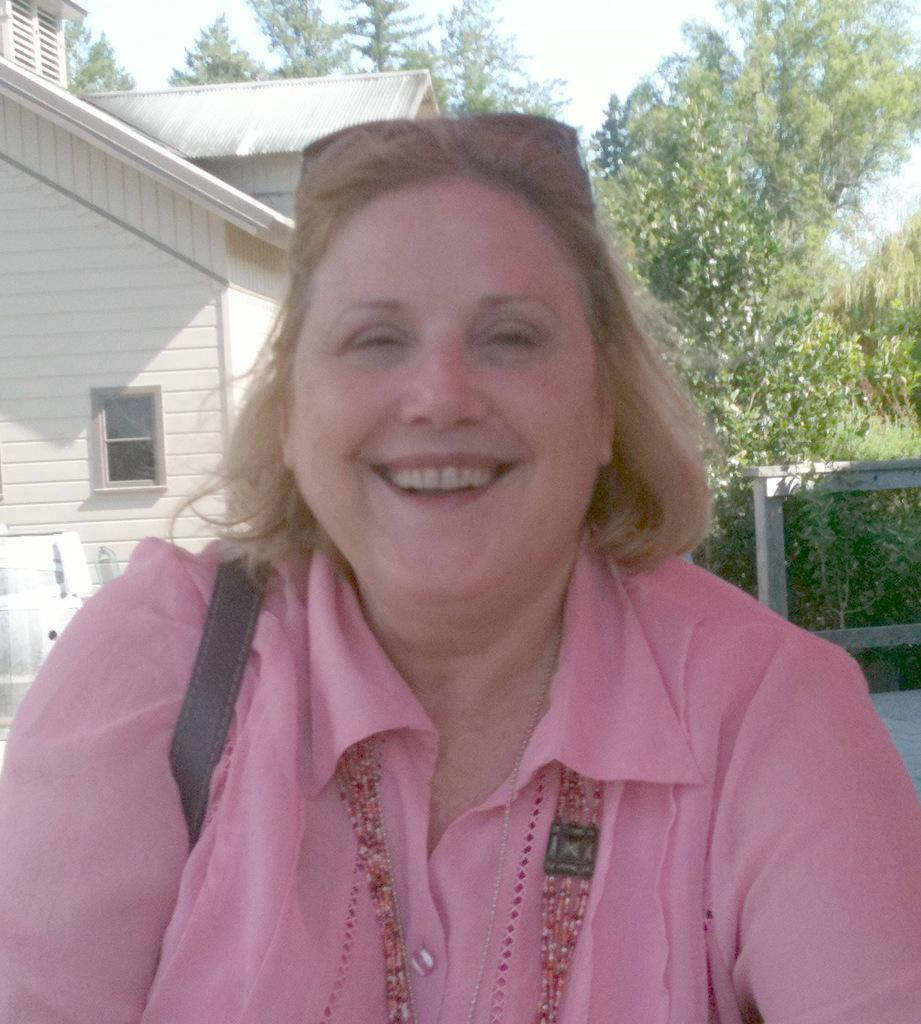Who is present in the image? There is a woman in the image. What is the woman's expression? The woman is smiling. What can be seen in the background of the image? There are homes and green color trees in the background of the image. What is visible at the top of the image? The sky is visible at the top of the image. How many parts of the dog can be seen in the image? There are no dogs present in the image, so it is not possible to see any parts of a dog. 